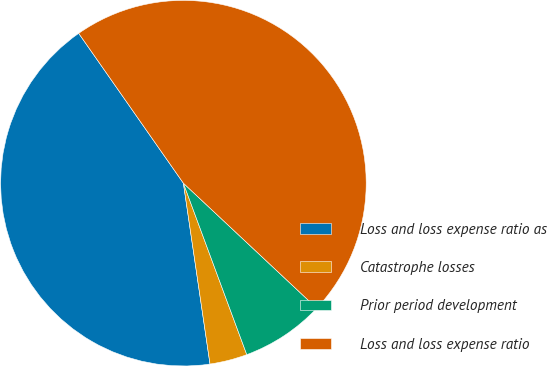Convert chart to OTSL. <chart><loc_0><loc_0><loc_500><loc_500><pie_chart><fcel>Loss and loss expense ratio as<fcel>Catastrophe losses<fcel>Prior period development<fcel>Loss and loss expense ratio<nl><fcel>42.62%<fcel>3.31%<fcel>7.38%<fcel>46.69%<nl></chart> 